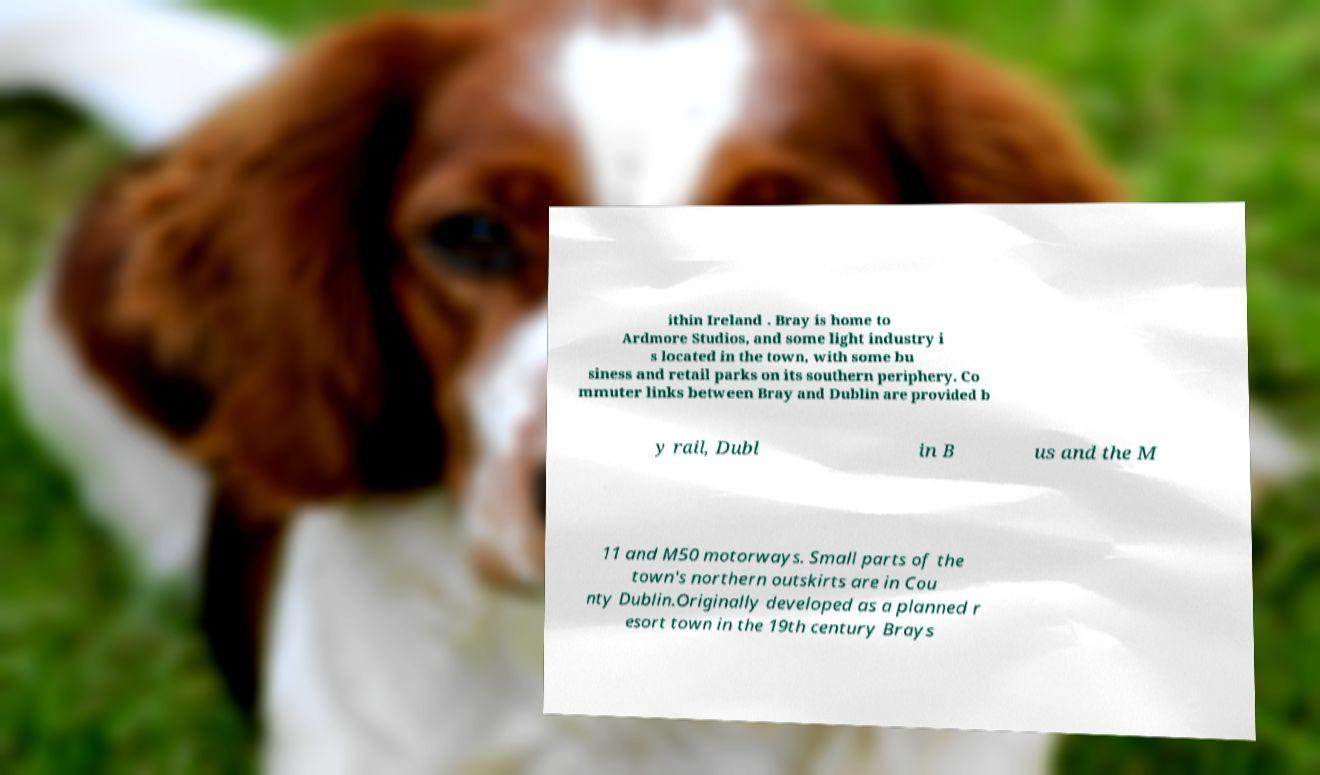There's text embedded in this image that I need extracted. Can you transcribe it verbatim? ithin Ireland . Bray is home to Ardmore Studios, and some light industry i s located in the town, with some bu siness and retail parks on its southern periphery. Co mmuter links between Bray and Dublin are provided b y rail, Dubl in B us and the M 11 and M50 motorways. Small parts of the town's northern outskirts are in Cou nty Dublin.Originally developed as a planned r esort town in the 19th century Brays 